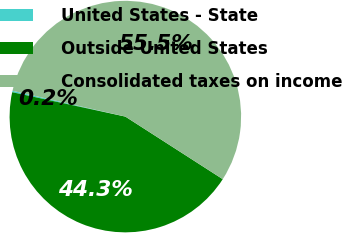Convert chart. <chart><loc_0><loc_0><loc_500><loc_500><pie_chart><fcel>United States - State<fcel>Outside United States<fcel>Consolidated taxes on income<nl><fcel>0.2%<fcel>44.29%<fcel>55.51%<nl></chart> 